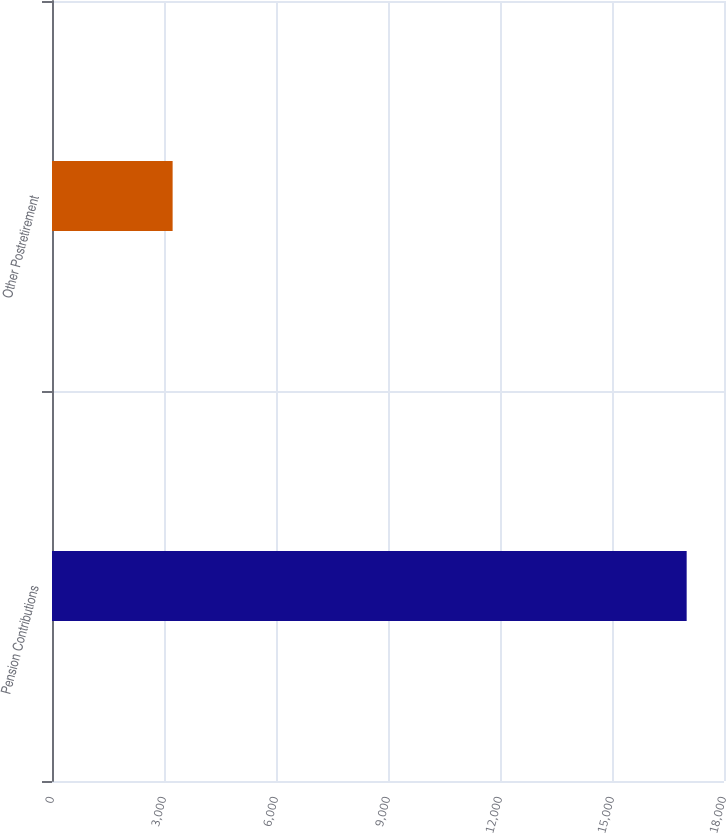<chart> <loc_0><loc_0><loc_500><loc_500><bar_chart><fcel>Pension Contributions<fcel>Other Postretirement<nl><fcel>17000<fcel>3231<nl></chart> 